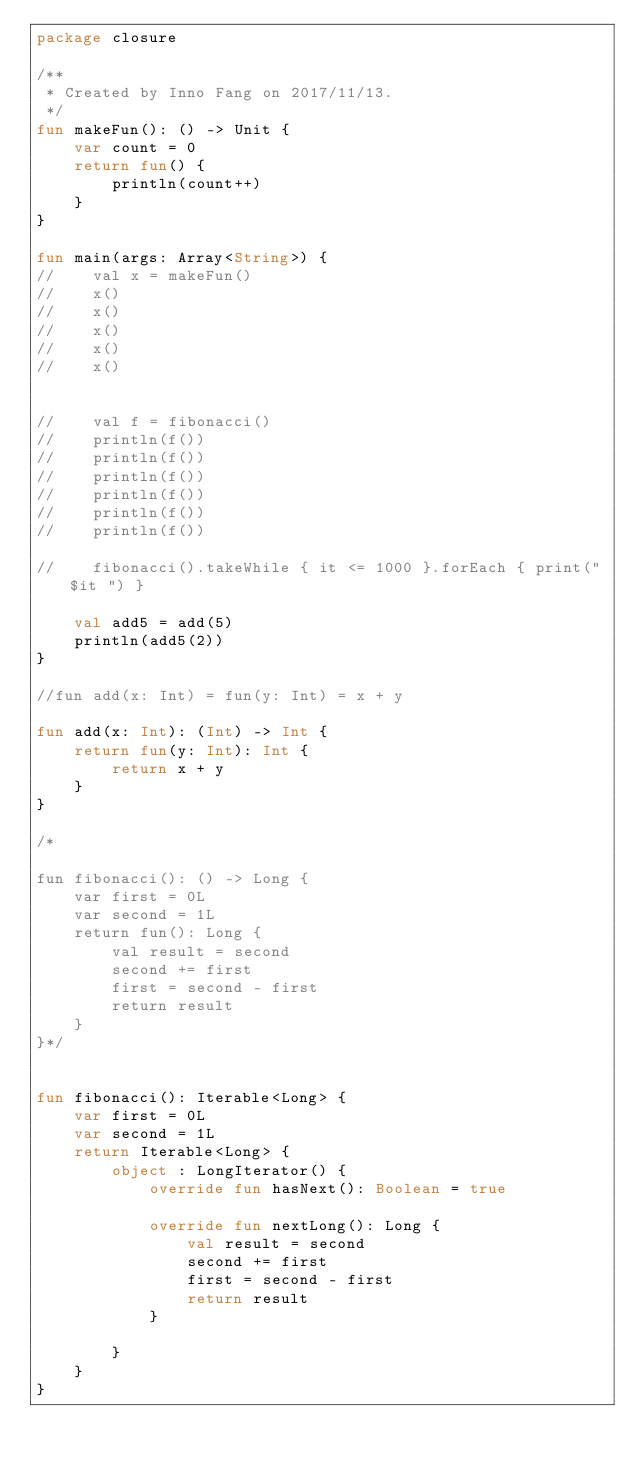<code> <loc_0><loc_0><loc_500><loc_500><_Kotlin_>package closure

/**
 * Created by Inno Fang on 2017/11/13.
 */
fun makeFun(): () -> Unit {
    var count = 0
    return fun() {
        println(count++)
    }
}

fun main(args: Array<String>) {
//    val x = makeFun()
//    x()
//    x()
//    x()
//    x()
//    x()


//    val f = fibonacci()
//    println(f())
//    println(f())
//    println(f())
//    println(f())
//    println(f())
//    println(f())

//    fibonacci().takeWhile { it <= 1000 }.forEach { print("$it ") }

    val add5 = add(5)
    println(add5(2))
}

//fun add(x: Int) = fun(y: Int) = x + y

fun add(x: Int): (Int) -> Int {
    return fun(y: Int): Int {
        return x + y
    }
}

/*

fun fibonacci(): () -> Long {
    var first = 0L
    var second = 1L
    return fun(): Long {
        val result = second
        second += first
        first = second - first
        return result
    }
}*/


fun fibonacci(): Iterable<Long> {
    var first = 0L
    var second = 1L
    return Iterable<Long> {
        object : LongIterator() {
            override fun hasNext(): Boolean = true

            override fun nextLong(): Long {
                val result = second
                second += first
                first = second - first
                return result
            }

        }
    }
}
</code> 